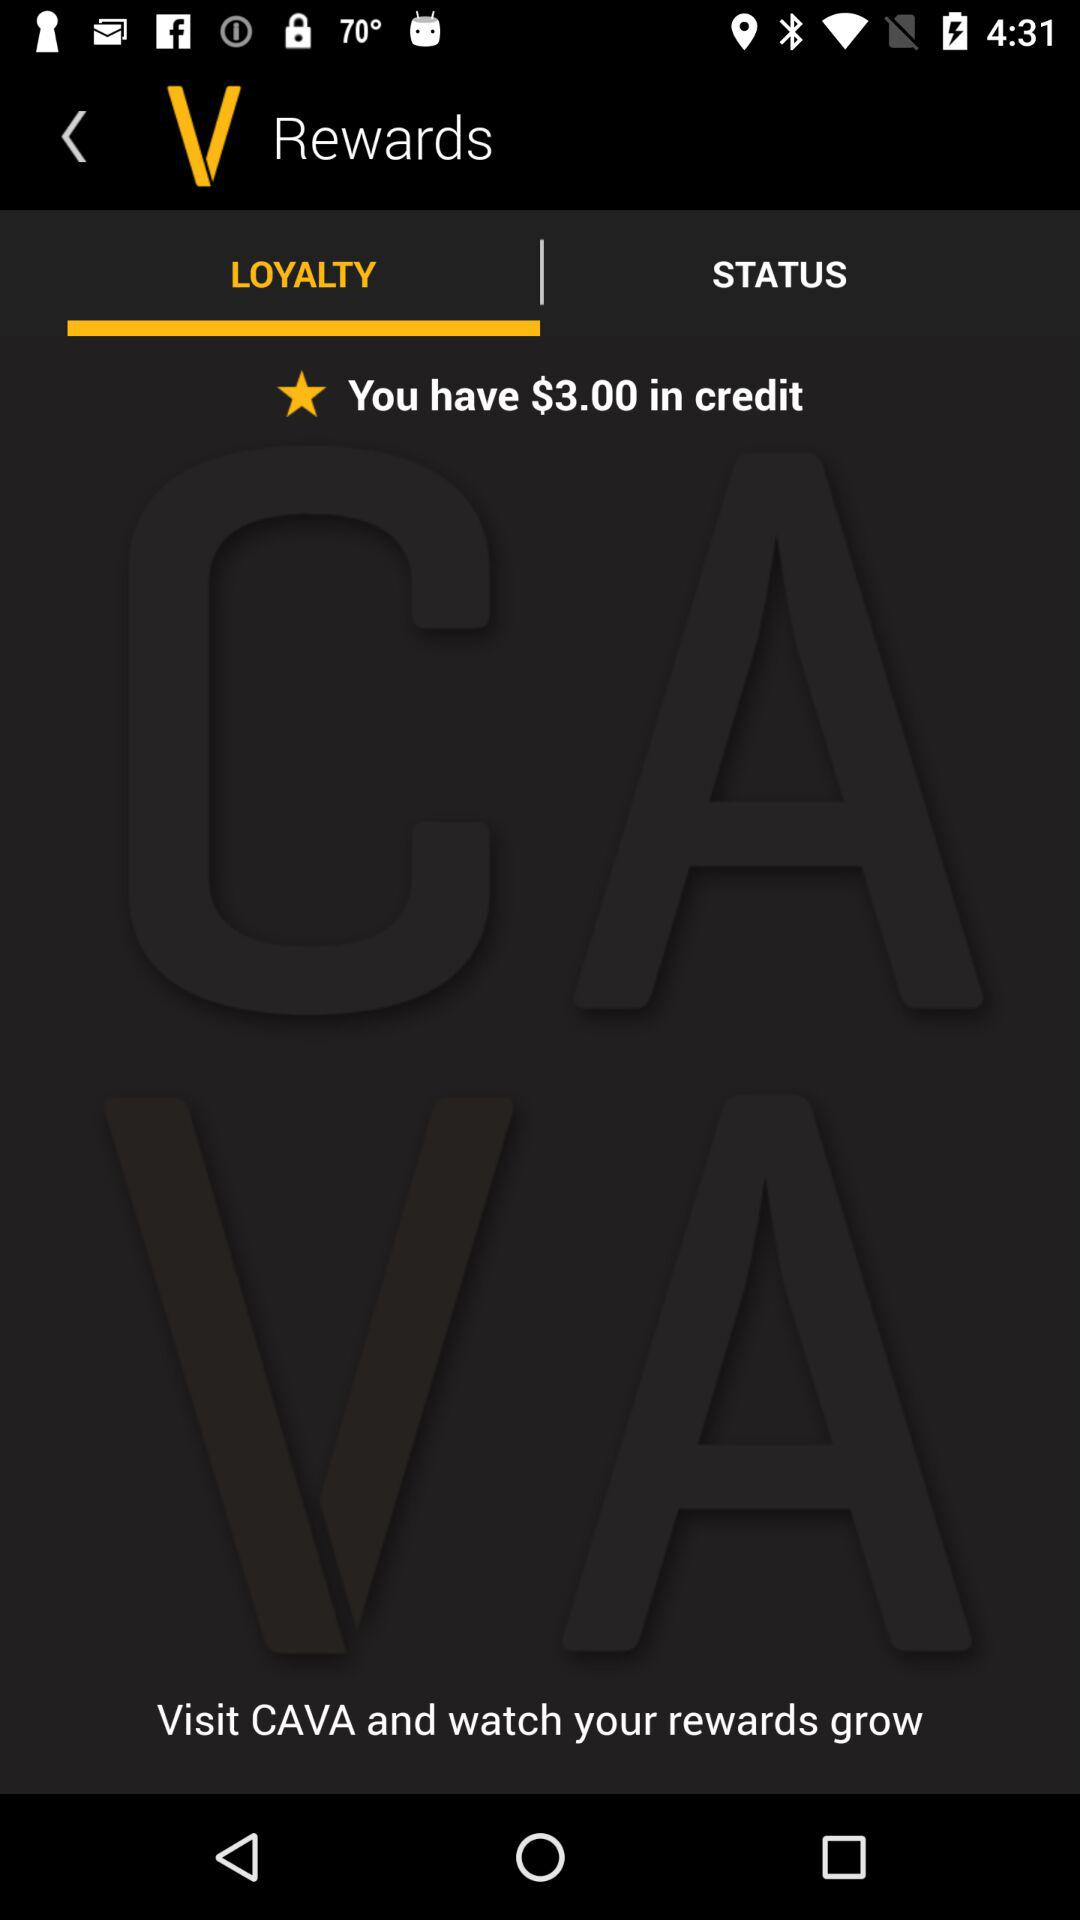How many more dollars do I need to get to $5 in credit?
Answer the question using a single word or phrase. 2 